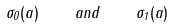Convert formula to latex. <formula><loc_0><loc_0><loc_500><loc_500>\sigma _ { 0 } ( a ) \quad a n d \quad \sigma _ { 1 } ( a )</formula> 